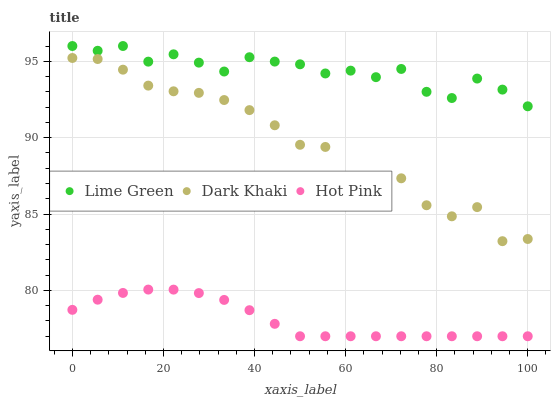Does Hot Pink have the minimum area under the curve?
Answer yes or no. Yes. Does Lime Green have the maximum area under the curve?
Answer yes or no. Yes. Does Lime Green have the minimum area under the curve?
Answer yes or no. No. Does Hot Pink have the maximum area under the curve?
Answer yes or no. No. Is Hot Pink the smoothest?
Answer yes or no. Yes. Is Dark Khaki the roughest?
Answer yes or no. Yes. Is Lime Green the smoothest?
Answer yes or no. No. Is Lime Green the roughest?
Answer yes or no. No. Does Hot Pink have the lowest value?
Answer yes or no. Yes. Does Lime Green have the lowest value?
Answer yes or no. No. Does Lime Green have the highest value?
Answer yes or no. Yes. Does Hot Pink have the highest value?
Answer yes or no. No. Is Hot Pink less than Lime Green?
Answer yes or no. Yes. Is Lime Green greater than Dark Khaki?
Answer yes or no. Yes. Does Hot Pink intersect Lime Green?
Answer yes or no. No. 